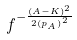<formula> <loc_0><loc_0><loc_500><loc_500>f ^ { - \frac { ( A - K ) ^ { 2 } } { 2 { ( p _ { A } ) } ^ { 2 } } }</formula> 